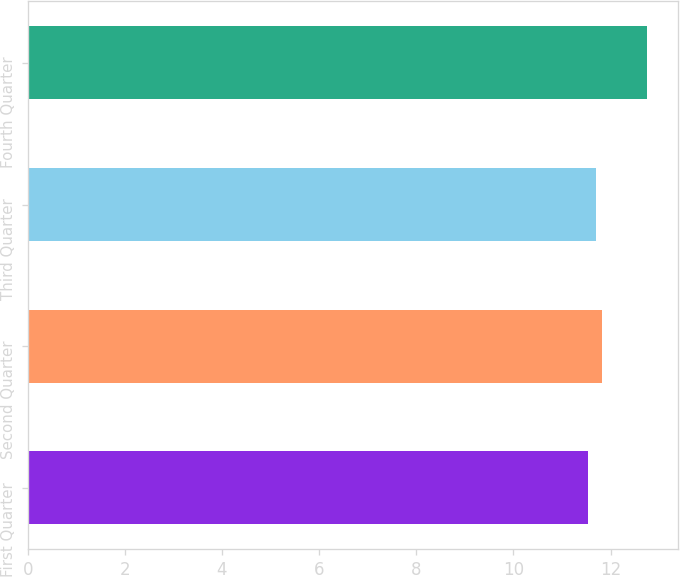Convert chart. <chart><loc_0><loc_0><loc_500><loc_500><bar_chart><fcel>First Quarter<fcel>Second Quarter<fcel>Third Quarter<fcel>Fourth Quarter<nl><fcel>11.54<fcel>11.82<fcel>11.7<fcel>12.75<nl></chart> 